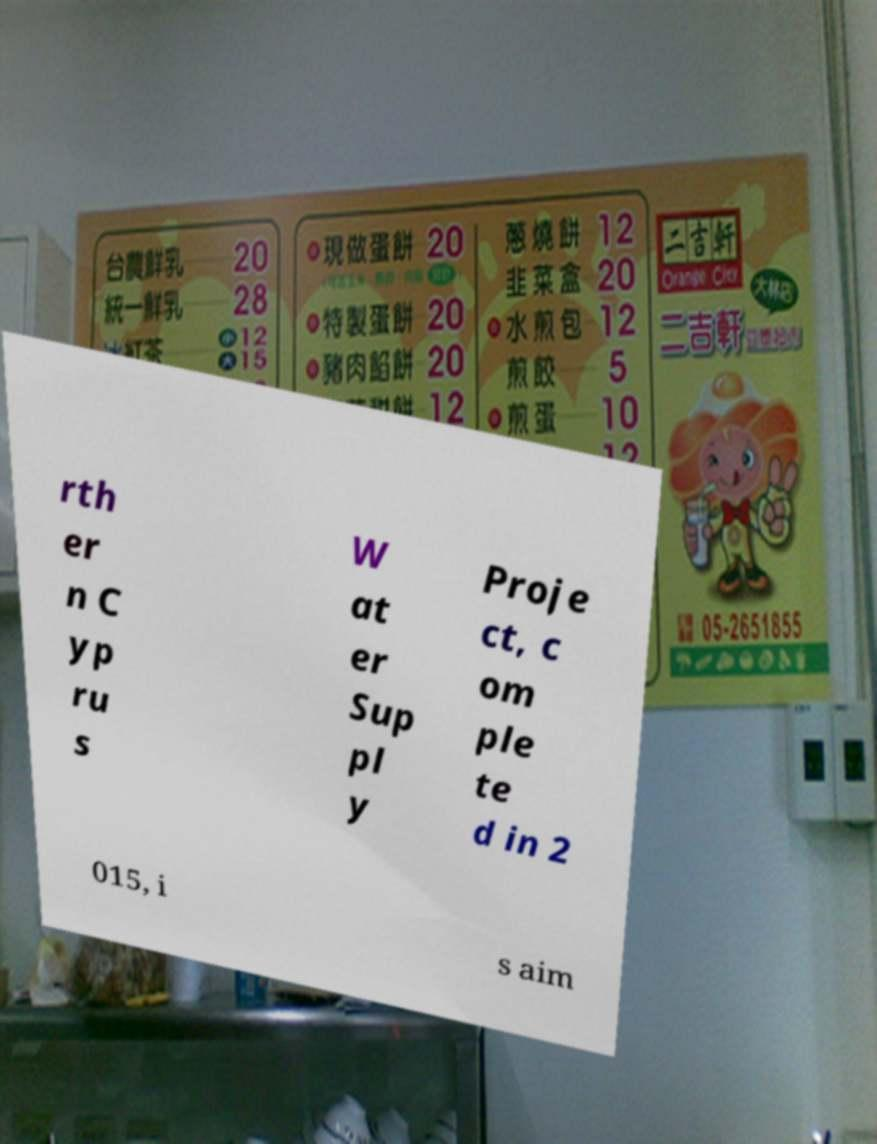What messages or text are displayed in this image? I need them in a readable, typed format. rth er n C yp ru s W at er Sup pl y Proje ct, c om ple te d in 2 015, i s aim 